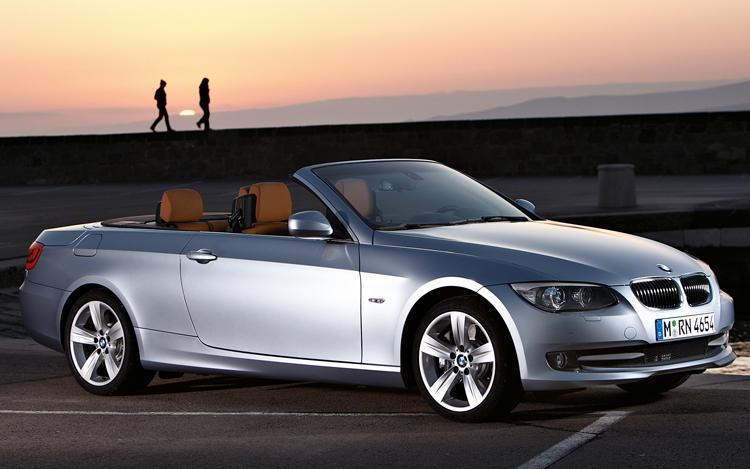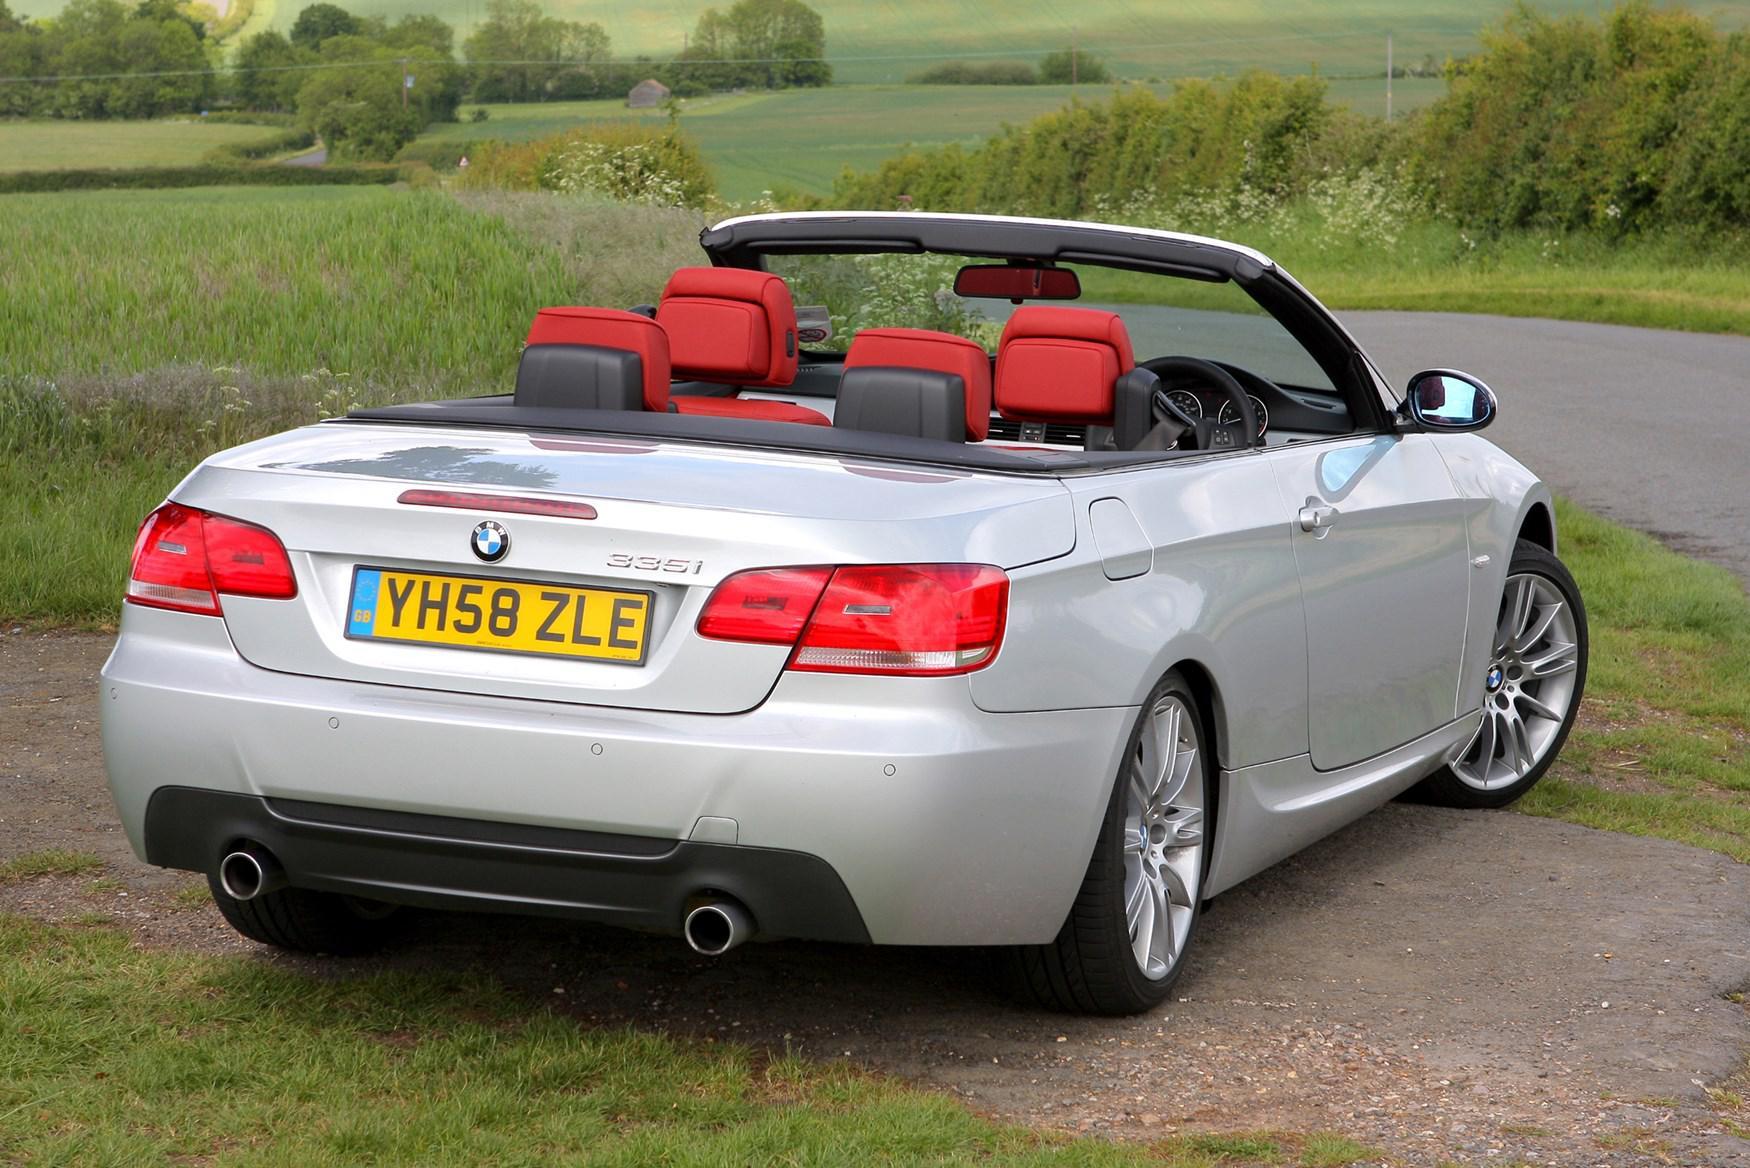The first image is the image on the left, the second image is the image on the right. Analyze the images presented: Is the assertion "AN image contains a blue convertible sports car." valid? Answer yes or no. No. The first image is the image on the left, the second image is the image on the right. Assess this claim about the two images: "An image shows a forward-facing royal blue convertible with some type of wall behind it.". Correct or not? Answer yes or no. No. 